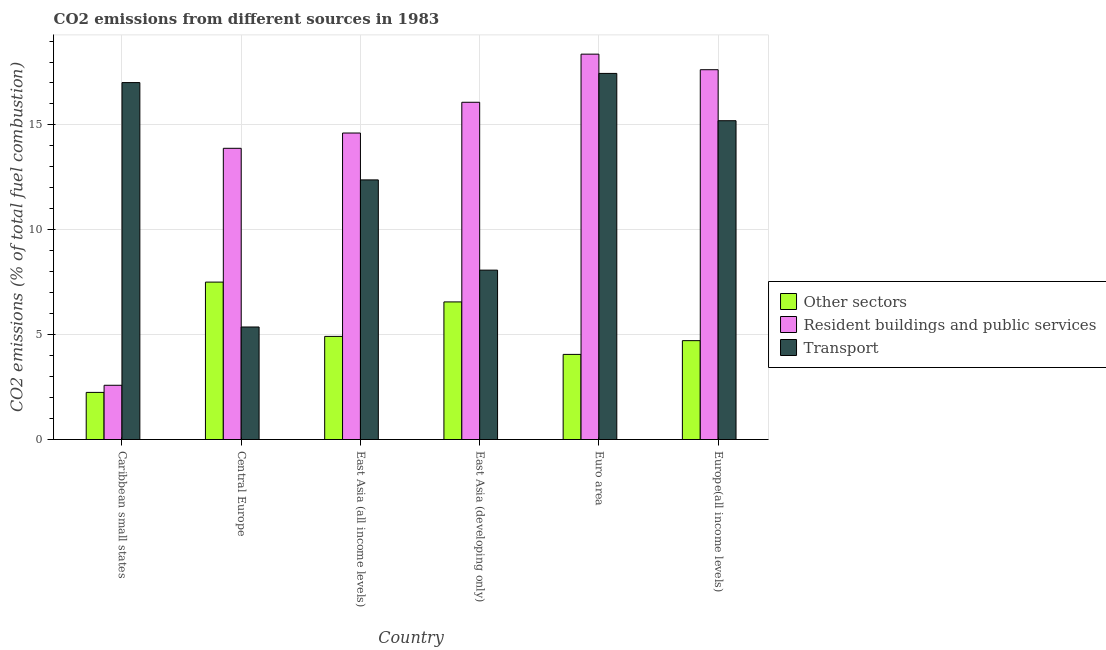Are the number of bars per tick equal to the number of legend labels?
Offer a terse response. Yes. How many bars are there on the 2nd tick from the right?
Offer a very short reply. 3. In how many cases, is the number of bars for a given country not equal to the number of legend labels?
Make the answer very short. 0. What is the percentage of co2 emissions from transport in Europe(all income levels)?
Provide a short and direct response. 15.2. Across all countries, what is the maximum percentage of co2 emissions from other sectors?
Give a very brief answer. 7.51. Across all countries, what is the minimum percentage of co2 emissions from other sectors?
Your answer should be very brief. 2.25. In which country was the percentage of co2 emissions from other sectors maximum?
Your answer should be compact. Central Europe. In which country was the percentage of co2 emissions from transport minimum?
Your answer should be very brief. Central Europe. What is the total percentage of co2 emissions from transport in the graph?
Keep it short and to the point. 75.5. What is the difference between the percentage of co2 emissions from other sectors in Euro area and that in Europe(all income levels)?
Make the answer very short. -0.66. What is the difference between the percentage of co2 emissions from transport in Euro area and the percentage of co2 emissions from resident buildings and public services in Europe(all income levels)?
Your answer should be very brief. -0.18. What is the average percentage of co2 emissions from other sectors per country?
Ensure brevity in your answer.  5. What is the difference between the percentage of co2 emissions from other sectors and percentage of co2 emissions from resident buildings and public services in Europe(all income levels)?
Keep it short and to the point. -12.92. In how many countries, is the percentage of co2 emissions from other sectors greater than 4 %?
Your answer should be very brief. 5. What is the ratio of the percentage of co2 emissions from other sectors in Central Europe to that in East Asia (developing only)?
Your response must be concise. 1.14. Is the percentage of co2 emissions from resident buildings and public services in Central Europe less than that in East Asia (all income levels)?
Your answer should be compact. Yes. Is the difference between the percentage of co2 emissions from other sectors in Central Europe and Euro area greater than the difference between the percentage of co2 emissions from transport in Central Europe and Euro area?
Your answer should be very brief. Yes. What is the difference between the highest and the second highest percentage of co2 emissions from transport?
Offer a very short reply. 0.44. What is the difference between the highest and the lowest percentage of co2 emissions from other sectors?
Your answer should be compact. 5.26. In how many countries, is the percentage of co2 emissions from resident buildings and public services greater than the average percentage of co2 emissions from resident buildings and public services taken over all countries?
Provide a short and direct response. 5. What does the 3rd bar from the left in Caribbean small states represents?
Give a very brief answer. Transport. What does the 3rd bar from the right in East Asia (all income levels) represents?
Offer a very short reply. Other sectors. Are all the bars in the graph horizontal?
Provide a succinct answer. No. How many countries are there in the graph?
Keep it short and to the point. 6. How are the legend labels stacked?
Offer a very short reply. Vertical. What is the title of the graph?
Give a very brief answer. CO2 emissions from different sources in 1983. What is the label or title of the Y-axis?
Give a very brief answer. CO2 emissions (% of total fuel combustion). What is the CO2 emissions (% of total fuel combustion) of Other sectors in Caribbean small states?
Ensure brevity in your answer.  2.25. What is the CO2 emissions (% of total fuel combustion) of Resident buildings and public services in Caribbean small states?
Your answer should be very brief. 2.59. What is the CO2 emissions (% of total fuel combustion) of Transport in Caribbean small states?
Provide a succinct answer. 17.02. What is the CO2 emissions (% of total fuel combustion) in Other sectors in Central Europe?
Offer a very short reply. 7.51. What is the CO2 emissions (% of total fuel combustion) of Resident buildings and public services in Central Europe?
Give a very brief answer. 13.88. What is the CO2 emissions (% of total fuel combustion) of Transport in Central Europe?
Offer a terse response. 5.37. What is the CO2 emissions (% of total fuel combustion) of Other sectors in East Asia (all income levels)?
Your response must be concise. 4.92. What is the CO2 emissions (% of total fuel combustion) in Resident buildings and public services in East Asia (all income levels)?
Your answer should be very brief. 14.61. What is the CO2 emissions (% of total fuel combustion) of Transport in East Asia (all income levels)?
Give a very brief answer. 12.38. What is the CO2 emissions (% of total fuel combustion) of Other sectors in East Asia (developing only)?
Offer a terse response. 6.56. What is the CO2 emissions (% of total fuel combustion) in Resident buildings and public services in East Asia (developing only)?
Your answer should be compact. 16.08. What is the CO2 emissions (% of total fuel combustion) in Transport in East Asia (developing only)?
Offer a terse response. 8.08. What is the CO2 emissions (% of total fuel combustion) of Other sectors in Euro area?
Ensure brevity in your answer.  4.06. What is the CO2 emissions (% of total fuel combustion) in Resident buildings and public services in Euro area?
Give a very brief answer. 18.37. What is the CO2 emissions (% of total fuel combustion) of Transport in Euro area?
Offer a terse response. 17.46. What is the CO2 emissions (% of total fuel combustion) of Other sectors in Europe(all income levels)?
Give a very brief answer. 4.71. What is the CO2 emissions (% of total fuel combustion) of Resident buildings and public services in Europe(all income levels)?
Your response must be concise. 17.63. What is the CO2 emissions (% of total fuel combustion) in Transport in Europe(all income levels)?
Make the answer very short. 15.2. Across all countries, what is the maximum CO2 emissions (% of total fuel combustion) of Other sectors?
Offer a very short reply. 7.51. Across all countries, what is the maximum CO2 emissions (% of total fuel combustion) of Resident buildings and public services?
Your answer should be compact. 18.37. Across all countries, what is the maximum CO2 emissions (% of total fuel combustion) of Transport?
Make the answer very short. 17.46. Across all countries, what is the minimum CO2 emissions (% of total fuel combustion) of Other sectors?
Offer a very short reply. 2.25. Across all countries, what is the minimum CO2 emissions (% of total fuel combustion) in Resident buildings and public services?
Keep it short and to the point. 2.59. Across all countries, what is the minimum CO2 emissions (% of total fuel combustion) in Transport?
Provide a short and direct response. 5.37. What is the total CO2 emissions (% of total fuel combustion) in Other sectors in the graph?
Ensure brevity in your answer.  30. What is the total CO2 emissions (% of total fuel combustion) in Resident buildings and public services in the graph?
Give a very brief answer. 83.17. What is the total CO2 emissions (% of total fuel combustion) in Transport in the graph?
Ensure brevity in your answer.  75.5. What is the difference between the CO2 emissions (% of total fuel combustion) of Other sectors in Caribbean small states and that in Central Europe?
Keep it short and to the point. -5.26. What is the difference between the CO2 emissions (% of total fuel combustion) of Resident buildings and public services in Caribbean small states and that in Central Europe?
Offer a terse response. -11.3. What is the difference between the CO2 emissions (% of total fuel combustion) of Transport in Caribbean small states and that in Central Europe?
Make the answer very short. 11.65. What is the difference between the CO2 emissions (% of total fuel combustion) of Other sectors in Caribbean small states and that in East Asia (all income levels)?
Provide a succinct answer. -2.67. What is the difference between the CO2 emissions (% of total fuel combustion) of Resident buildings and public services in Caribbean small states and that in East Asia (all income levels)?
Make the answer very short. -12.03. What is the difference between the CO2 emissions (% of total fuel combustion) of Transport in Caribbean small states and that in East Asia (all income levels)?
Your response must be concise. 4.64. What is the difference between the CO2 emissions (% of total fuel combustion) in Other sectors in Caribbean small states and that in East Asia (developing only)?
Your response must be concise. -4.31. What is the difference between the CO2 emissions (% of total fuel combustion) in Resident buildings and public services in Caribbean small states and that in East Asia (developing only)?
Your response must be concise. -13.49. What is the difference between the CO2 emissions (% of total fuel combustion) in Transport in Caribbean small states and that in East Asia (developing only)?
Give a very brief answer. 8.94. What is the difference between the CO2 emissions (% of total fuel combustion) of Other sectors in Caribbean small states and that in Euro area?
Your answer should be compact. -1.81. What is the difference between the CO2 emissions (% of total fuel combustion) of Resident buildings and public services in Caribbean small states and that in Euro area?
Make the answer very short. -15.79. What is the difference between the CO2 emissions (% of total fuel combustion) of Transport in Caribbean small states and that in Euro area?
Your answer should be very brief. -0.44. What is the difference between the CO2 emissions (% of total fuel combustion) of Other sectors in Caribbean small states and that in Europe(all income levels)?
Offer a very short reply. -2.47. What is the difference between the CO2 emissions (% of total fuel combustion) of Resident buildings and public services in Caribbean small states and that in Europe(all income levels)?
Your response must be concise. -15.05. What is the difference between the CO2 emissions (% of total fuel combustion) in Transport in Caribbean small states and that in Europe(all income levels)?
Your answer should be compact. 1.82. What is the difference between the CO2 emissions (% of total fuel combustion) of Other sectors in Central Europe and that in East Asia (all income levels)?
Provide a succinct answer. 2.59. What is the difference between the CO2 emissions (% of total fuel combustion) of Resident buildings and public services in Central Europe and that in East Asia (all income levels)?
Ensure brevity in your answer.  -0.73. What is the difference between the CO2 emissions (% of total fuel combustion) in Transport in Central Europe and that in East Asia (all income levels)?
Make the answer very short. -7.01. What is the difference between the CO2 emissions (% of total fuel combustion) in Other sectors in Central Europe and that in East Asia (developing only)?
Offer a very short reply. 0.94. What is the difference between the CO2 emissions (% of total fuel combustion) of Resident buildings and public services in Central Europe and that in East Asia (developing only)?
Ensure brevity in your answer.  -2.2. What is the difference between the CO2 emissions (% of total fuel combustion) in Transport in Central Europe and that in East Asia (developing only)?
Offer a terse response. -2.71. What is the difference between the CO2 emissions (% of total fuel combustion) of Other sectors in Central Europe and that in Euro area?
Provide a succinct answer. 3.45. What is the difference between the CO2 emissions (% of total fuel combustion) of Resident buildings and public services in Central Europe and that in Euro area?
Provide a short and direct response. -4.49. What is the difference between the CO2 emissions (% of total fuel combustion) of Transport in Central Europe and that in Euro area?
Offer a very short reply. -12.09. What is the difference between the CO2 emissions (% of total fuel combustion) in Other sectors in Central Europe and that in Europe(all income levels)?
Provide a succinct answer. 2.79. What is the difference between the CO2 emissions (% of total fuel combustion) in Resident buildings and public services in Central Europe and that in Europe(all income levels)?
Provide a short and direct response. -3.75. What is the difference between the CO2 emissions (% of total fuel combustion) of Transport in Central Europe and that in Europe(all income levels)?
Keep it short and to the point. -9.84. What is the difference between the CO2 emissions (% of total fuel combustion) of Other sectors in East Asia (all income levels) and that in East Asia (developing only)?
Ensure brevity in your answer.  -1.64. What is the difference between the CO2 emissions (% of total fuel combustion) in Resident buildings and public services in East Asia (all income levels) and that in East Asia (developing only)?
Offer a very short reply. -1.47. What is the difference between the CO2 emissions (% of total fuel combustion) of Transport in East Asia (all income levels) and that in East Asia (developing only)?
Offer a very short reply. 4.3. What is the difference between the CO2 emissions (% of total fuel combustion) in Other sectors in East Asia (all income levels) and that in Euro area?
Offer a very short reply. 0.86. What is the difference between the CO2 emissions (% of total fuel combustion) in Resident buildings and public services in East Asia (all income levels) and that in Euro area?
Provide a short and direct response. -3.76. What is the difference between the CO2 emissions (% of total fuel combustion) in Transport in East Asia (all income levels) and that in Euro area?
Ensure brevity in your answer.  -5.08. What is the difference between the CO2 emissions (% of total fuel combustion) of Other sectors in East Asia (all income levels) and that in Europe(all income levels)?
Your answer should be very brief. 0.2. What is the difference between the CO2 emissions (% of total fuel combustion) of Resident buildings and public services in East Asia (all income levels) and that in Europe(all income levels)?
Your answer should be very brief. -3.02. What is the difference between the CO2 emissions (% of total fuel combustion) of Transport in East Asia (all income levels) and that in Europe(all income levels)?
Your answer should be compact. -2.82. What is the difference between the CO2 emissions (% of total fuel combustion) of Other sectors in East Asia (developing only) and that in Euro area?
Provide a short and direct response. 2.5. What is the difference between the CO2 emissions (% of total fuel combustion) of Resident buildings and public services in East Asia (developing only) and that in Euro area?
Offer a very short reply. -2.29. What is the difference between the CO2 emissions (% of total fuel combustion) of Transport in East Asia (developing only) and that in Euro area?
Your answer should be very brief. -9.38. What is the difference between the CO2 emissions (% of total fuel combustion) in Other sectors in East Asia (developing only) and that in Europe(all income levels)?
Provide a short and direct response. 1.85. What is the difference between the CO2 emissions (% of total fuel combustion) in Resident buildings and public services in East Asia (developing only) and that in Europe(all income levels)?
Your answer should be very brief. -1.55. What is the difference between the CO2 emissions (% of total fuel combustion) of Transport in East Asia (developing only) and that in Europe(all income levels)?
Provide a short and direct response. -7.12. What is the difference between the CO2 emissions (% of total fuel combustion) in Other sectors in Euro area and that in Europe(all income levels)?
Make the answer very short. -0.66. What is the difference between the CO2 emissions (% of total fuel combustion) in Resident buildings and public services in Euro area and that in Europe(all income levels)?
Provide a short and direct response. 0.74. What is the difference between the CO2 emissions (% of total fuel combustion) of Transport in Euro area and that in Europe(all income levels)?
Provide a short and direct response. 2.26. What is the difference between the CO2 emissions (% of total fuel combustion) in Other sectors in Caribbean small states and the CO2 emissions (% of total fuel combustion) in Resident buildings and public services in Central Europe?
Your answer should be very brief. -11.64. What is the difference between the CO2 emissions (% of total fuel combustion) of Other sectors in Caribbean small states and the CO2 emissions (% of total fuel combustion) of Transport in Central Europe?
Provide a succinct answer. -3.12. What is the difference between the CO2 emissions (% of total fuel combustion) in Resident buildings and public services in Caribbean small states and the CO2 emissions (% of total fuel combustion) in Transport in Central Europe?
Offer a terse response. -2.78. What is the difference between the CO2 emissions (% of total fuel combustion) of Other sectors in Caribbean small states and the CO2 emissions (% of total fuel combustion) of Resident buildings and public services in East Asia (all income levels)?
Provide a succinct answer. -12.37. What is the difference between the CO2 emissions (% of total fuel combustion) of Other sectors in Caribbean small states and the CO2 emissions (% of total fuel combustion) of Transport in East Asia (all income levels)?
Your response must be concise. -10.13. What is the difference between the CO2 emissions (% of total fuel combustion) in Resident buildings and public services in Caribbean small states and the CO2 emissions (% of total fuel combustion) in Transport in East Asia (all income levels)?
Your response must be concise. -9.79. What is the difference between the CO2 emissions (% of total fuel combustion) in Other sectors in Caribbean small states and the CO2 emissions (% of total fuel combustion) in Resident buildings and public services in East Asia (developing only)?
Provide a succinct answer. -13.83. What is the difference between the CO2 emissions (% of total fuel combustion) of Other sectors in Caribbean small states and the CO2 emissions (% of total fuel combustion) of Transport in East Asia (developing only)?
Make the answer very short. -5.83. What is the difference between the CO2 emissions (% of total fuel combustion) in Resident buildings and public services in Caribbean small states and the CO2 emissions (% of total fuel combustion) in Transport in East Asia (developing only)?
Your answer should be very brief. -5.49. What is the difference between the CO2 emissions (% of total fuel combustion) of Other sectors in Caribbean small states and the CO2 emissions (% of total fuel combustion) of Resident buildings and public services in Euro area?
Your answer should be compact. -16.13. What is the difference between the CO2 emissions (% of total fuel combustion) of Other sectors in Caribbean small states and the CO2 emissions (% of total fuel combustion) of Transport in Euro area?
Your answer should be very brief. -15.21. What is the difference between the CO2 emissions (% of total fuel combustion) in Resident buildings and public services in Caribbean small states and the CO2 emissions (% of total fuel combustion) in Transport in Euro area?
Keep it short and to the point. -14.87. What is the difference between the CO2 emissions (% of total fuel combustion) in Other sectors in Caribbean small states and the CO2 emissions (% of total fuel combustion) in Resident buildings and public services in Europe(all income levels)?
Provide a succinct answer. -15.39. What is the difference between the CO2 emissions (% of total fuel combustion) in Other sectors in Caribbean small states and the CO2 emissions (% of total fuel combustion) in Transport in Europe(all income levels)?
Ensure brevity in your answer.  -12.95. What is the difference between the CO2 emissions (% of total fuel combustion) in Resident buildings and public services in Caribbean small states and the CO2 emissions (% of total fuel combustion) in Transport in Europe(all income levels)?
Provide a short and direct response. -12.61. What is the difference between the CO2 emissions (% of total fuel combustion) of Other sectors in Central Europe and the CO2 emissions (% of total fuel combustion) of Resident buildings and public services in East Asia (all income levels)?
Offer a terse response. -7.11. What is the difference between the CO2 emissions (% of total fuel combustion) in Other sectors in Central Europe and the CO2 emissions (% of total fuel combustion) in Transport in East Asia (all income levels)?
Your response must be concise. -4.87. What is the difference between the CO2 emissions (% of total fuel combustion) in Resident buildings and public services in Central Europe and the CO2 emissions (% of total fuel combustion) in Transport in East Asia (all income levels)?
Offer a terse response. 1.51. What is the difference between the CO2 emissions (% of total fuel combustion) of Other sectors in Central Europe and the CO2 emissions (% of total fuel combustion) of Resident buildings and public services in East Asia (developing only)?
Make the answer very short. -8.57. What is the difference between the CO2 emissions (% of total fuel combustion) of Other sectors in Central Europe and the CO2 emissions (% of total fuel combustion) of Transport in East Asia (developing only)?
Provide a succinct answer. -0.57. What is the difference between the CO2 emissions (% of total fuel combustion) of Resident buildings and public services in Central Europe and the CO2 emissions (% of total fuel combustion) of Transport in East Asia (developing only)?
Keep it short and to the point. 5.81. What is the difference between the CO2 emissions (% of total fuel combustion) in Other sectors in Central Europe and the CO2 emissions (% of total fuel combustion) in Resident buildings and public services in Euro area?
Offer a terse response. -10.87. What is the difference between the CO2 emissions (% of total fuel combustion) of Other sectors in Central Europe and the CO2 emissions (% of total fuel combustion) of Transport in Euro area?
Keep it short and to the point. -9.95. What is the difference between the CO2 emissions (% of total fuel combustion) of Resident buildings and public services in Central Europe and the CO2 emissions (% of total fuel combustion) of Transport in Euro area?
Offer a terse response. -3.57. What is the difference between the CO2 emissions (% of total fuel combustion) of Other sectors in Central Europe and the CO2 emissions (% of total fuel combustion) of Resident buildings and public services in Europe(all income levels)?
Keep it short and to the point. -10.13. What is the difference between the CO2 emissions (% of total fuel combustion) of Other sectors in Central Europe and the CO2 emissions (% of total fuel combustion) of Transport in Europe(all income levels)?
Give a very brief answer. -7.7. What is the difference between the CO2 emissions (% of total fuel combustion) of Resident buildings and public services in Central Europe and the CO2 emissions (% of total fuel combustion) of Transport in Europe(all income levels)?
Offer a terse response. -1.32. What is the difference between the CO2 emissions (% of total fuel combustion) in Other sectors in East Asia (all income levels) and the CO2 emissions (% of total fuel combustion) in Resident buildings and public services in East Asia (developing only)?
Your answer should be compact. -11.16. What is the difference between the CO2 emissions (% of total fuel combustion) of Other sectors in East Asia (all income levels) and the CO2 emissions (% of total fuel combustion) of Transport in East Asia (developing only)?
Keep it short and to the point. -3.16. What is the difference between the CO2 emissions (% of total fuel combustion) of Resident buildings and public services in East Asia (all income levels) and the CO2 emissions (% of total fuel combustion) of Transport in East Asia (developing only)?
Your answer should be very brief. 6.54. What is the difference between the CO2 emissions (% of total fuel combustion) of Other sectors in East Asia (all income levels) and the CO2 emissions (% of total fuel combustion) of Resident buildings and public services in Euro area?
Offer a very short reply. -13.46. What is the difference between the CO2 emissions (% of total fuel combustion) in Other sectors in East Asia (all income levels) and the CO2 emissions (% of total fuel combustion) in Transport in Euro area?
Your answer should be very brief. -12.54. What is the difference between the CO2 emissions (% of total fuel combustion) of Resident buildings and public services in East Asia (all income levels) and the CO2 emissions (% of total fuel combustion) of Transport in Euro area?
Provide a short and direct response. -2.84. What is the difference between the CO2 emissions (% of total fuel combustion) of Other sectors in East Asia (all income levels) and the CO2 emissions (% of total fuel combustion) of Resident buildings and public services in Europe(all income levels)?
Offer a terse response. -12.72. What is the difference between the CO2 emissions (% of total fuel combustion) in Other sectors in East Asia (all income levels) and the CO2 emissions (% of total fuel combustion) in Transport in Europe(all income levels)?
Keep it short and to the point. -10.28. What is the difference between the CO2 emissions (% of total fuel combustion) in Resident buildings and public services in East Asia (all income levels) and the CO2 emissions (% of total fuel combustion) in Transport in Europe(all income levels)?
Your response must be concise. -0.59. What is the difference between the CO2 emissions (% of total fuel combustion) of Other sectors in East Asia (developing only) and the CO2 emissions (% of total fuel combustion) of Resident buildings and public services in Euro area?
Offer a terse response. -11.81. What is the difference between the CO2 emissions (% of total fuel combustion) of Other sectors in East Asia (developing only) and the CO2 emissions (% of total fuel combustion) of Transport in Euro area?
Offer a very short reply. -10.89. What is the difference between the CO2 emissions (% of total fuel combustion) in Resident buildings and public services in East Asia (developing only) and the CO2 emissions (% of total fuel combustion) in Transport in Euro area?
Ensure brevity in your answer.  -1.38. What is the difference between the CO2 emissions (% of total fuel combustion) in Other sectors in East Asia (developing only) and the CO2 emissions (% of total fuel combustion) in Resident buildings and public services in Europe(all income levels)?
Your answer should be very brief. -11.07. What is the difference between the CO2 emissions (% of total fuel combustion) in Other sectors in East Asia (developing only) and the CO2 emissions (% of total fuel combustion) in Transport in Europe(all income levels)?
Offer a very short reply. -8.64. What is the difference between the CO2 emissions (% of total fuel combustion) of Resident buildings and public services in East Asia (developing only) and the CO2 emissions (% of total fuel combustion) of Transport in Europe(all income levels)?
Keep it short and to the point. 0.88. What is the difference between the CO2 emissions (% of total fuel combustion) in Other sectors in Euro area and the CO2 emissions (% of total fuel combustion) in Resident buildings and public services in Europe(all income levels)?
Your response must be concise. -13.57. What is the difference between the CO2 emissions (% of total fuel combustion) in Other sectors in Euro area and the CO2 emissions (% of total fuel combustion) in Transport in Europe(all income levels)?
Make the answer very short. -11.14. What is the difference between the CO2 emissions (% of total fuel combustion) of Resident buildings and public services in Euro area and the CO2 emissions (% of total fuel combustion) of Transport in Europe(all income levels)?
Keep it short and to the point. 3.17. What is the average CO2 emissions (% of total fuel combustion) in Other sectors per country?
Make the answer very short. 5. What is the average CO2 emissions (% of total fuel combustion) in Resident buildings and public services per country?
Offer a terse response. 13.86. What is the average CO2 emissions (% of total fuel combustion) in Transport per country?
Provide a short and direct response. 12.58. What is the difference between the CO2 emissions (% of total fuel combustion) of Other sectors and CO2 emissions (% of total fuel combustion) of Resident buildings and public services in Caribbean small states?
Your response must be concise. -0.34. What is the difference between the CO2 emissions (% of total fuel combustion) in Other sectors and CO2 emissions (% of total fuel combustion) in Transport in Caribbean small states?
Your answer should be compact. -14.77. What is the difference between the CO2 emissions (% of total fuel combustion) of Resident buildings and public services and CO2 emissions (% of total fuel combustion) of Transport in Caribbean small states?
Your answer should be compact. -14.43. What is the difference between the CO2 emissions (% of total fuel combustion) in Other sectors and CO2 emissions (% of total fuel combustion) in Resident buildings and public services in Central Europe?
Ensure brevity in your answer.  -6.38. What is the difference between the CO2 emissions (% of total fuel combustion) of Other sectors and CO2 emissions (% of total fuel combustion) of Transport in Central Europe?
Your answer should be very brief. 2.14. What is the difference between the CO2 emissions (% of total fuel combustion) in Resident buildings and public services and CO2 emissions (% of total fuel combustion) in Transport in Central Europe?
Provide a short and direct response. 8.52. What is the difference between the CO2 emissions (% of total fuel combustion) in Other sectors and CO2 emissions (% of total fuel combustion) in Resident buildings and public services in East Asia (all income levels)?
Ensure brevity in your answer.  -9.7. What is the difference between the CO2 emissions (% of total fuel combustion) in Other sectors and CO2 emissions (% of total fuel combustion) in Transport in East Asia (all income levels)?
Keep it short and to the point. -7.46. What is the difference between the CO2 emissions (% of total fuel combustion) of Resident buildings and public services and CO2 emissions (% of total fuel combustion) of Transport in East Asia (all income levels)?
Offer a very short reply. 2.24. What is the difference between the CO2 emissions (% of total fuel combustion) of Other sectors and CO2 emissions (% of total fuel combustion) of Resident buildings and public services in East Asia (developing only)?
Your answer should be very brief. -9.52. What is the difference between the CO2 emissions (% of total fuel combustion) in Other sectors and CO2 emissions (% of total fuel combustion) in Transport in East Asia (developing only)?
Provide a succinct answer. -1.52. What is the difference between the CO2 emissions (% of total fuel combustion) of Resident buildings and public services and CO2 emissions (% of total fuel combustion) of Transport in East Asia (developing only)?
Provide a succinct answer. 8. What is the difference between the CO2 emissions (% of total fuel combustion) in Other sectors and CO2 emissions (% of total fuel combustion) in Resident buildings and public services in Euro area?
Your answer should be very brief. -14.32. What is the difference between the CO2 emissions (% of total fuel combustion) in Other sectors and CO2 emissions (% of total fuel combustion) in Transport in Euro area?
Your response must be concise. -13.4. What is the difference between the CO2 emissions (% of total fuel combustion) in Resident buildings and public services and CO2 emissions (% of total fuel combustion) in Transport in Euro area?
Your answer should be compact. 0.92. What is the difference between the CO2 emissions (% of total fuel combustion) in Other sectors and CO2 emissions (% of total fuel combustion) in Resident buildings and public services in Europe(all income levels)?
Keep it short and to the point. -12.92. What is the difference between the CO2 emissions (% of total fuel combustion) of Other sectors and CO2 emissions (% of total fuel combustion) of Transport in Europe(all income levels)?
Ensure brevity in your answer.  -10.49. What is the difference between the CO2 emissions (% of total fuel combustion) of Resident buildings and public services and CO2 emissions (% of total fuel combustion) of Transport in Europe(all income levels)?
Your response must be concise. 2.43. What is the ratio of the CO2 emissions (% of total fuel combustion) in Other sectors in Caribbean small states to that in Central Europe?
Ensure brevity in your answer.  0.3. What is the ratio of the CO2 emissions (% of total fuel combustion) of Resident buildings and public services in Caribbean small states to that in Central Europe?
Offer a very short reply. 0.19. What is the ratio of the CO2 emissions (% of total fuel combustion) of Transport in Caribbean small states to that in Central Europe?
Ensure brevity in your answer.  3.17. What is the ratio of the CO2 emissions (% of total fuel combustion) in Other sectors in Caribbean small states to that in East Asia (all income levels)?
Offer a very short reply. 0.46. What is the ratio of the CO2 emissions (% of total fuel combustion) in Resident buildings and public services in Caribbean small states to that in East Asia (all income levels)?
Your answer should be very brief. 0.18. What is the ratio of the CO2 emissions (% of total fuel combustion) in Transport in Caribbean small states to that in East Asia (all income levels)?
Ensure brevity in your answer.  1.37. What is the ratio of the CO2 emissions (% of total fuel combustion) in Other sectors in Caribbean small states to that in East Asia (developing only)?
Provide a succinct answer. 0.34. What is the ratio of the CO2 emissions (% of total fuel combustion) of Resident buildings and public services in Caribbean small states to that in East Asia (developing only)?
Make the answer very short. 0.16. What is the ratio of the CO2 emissions (% of total fuel combustion) in Transport in Caribbean small states to that in East Asia (developing only)?
Provide a succinct answer. 2.11. What is the ratio of the CO2 emissions (% of total fuel combustion) of Other sectors in Caribbean small states to that in Euro area?
Provide a short and direct response. 0.55. What is the ratio of the CO2 emissions (% of total fuel combustion) of Resident buildings and public services in Caribbean small states to that in Euro area?
Your answer should be very brief. 0.14. What is the ratio of the CO2 emissions (% of total fuel combustion) of Transport in Caribbean small states to that in Euro area?
Your answer should be compact. 0.97. What is the ratio of the CO2 emissions (% of total fuel combustion) of Other sectors in Caribbean small states to that in Europe(all income levels)?
Your response must be concise. 0.48. What is the ratio of the CO2 emissions (% of total fuel combustion) in Resident buildings and public services in Caribbean small states to that in Europe(all income levels)?
Your answer should be compact. 0.15. What is the ratio of the CO2 emissions (% of total fuel combustion) in Transport in Caribbean small states to that in Europe(all income levels)?
Offer a very short reply. 1.12. What is the ratio of the CO2 emissions (% of total fuel combustion) of Other sectors in Central Europe to that in East Asia (all income levels)?
Offer a very short reply. 1.53. What is the ratio of the CO2 emissions (% of total fuel combustion) of Resident buildings and public services in Central Europe to that in East Asia (all income levels)?
Offer a terse response. 0.95. What is the ratio of the CO2 emissions (% of total fuel combustion) of Transport in Central Europe to that in East Asia (all income levels)?
Make the answer very short. 0.43. What is the ratio of the CO2 emissions (% of total fuel combustion) in Other sectors in Central Europe to that in East Asia (developing only)?
Provide a succinct answer. 1.14. What is the ratio of the CO2 emissions (% of total fuel combustion) of Resident buildings and public services in Central Europe to that in East Asia (developing only)?
Offer a very short reply. 0.86. What is the ratio of the CO2 emissions (% of total fuel combustion) in Transport in Central Europe to that in East Asia (developing only)?
Give a very brief answer. 0.66. What is the ratio of the CO2 emissions (% of total fuel combustion) in Other sectors in Central Europe to that in Euro area?
Keep it short and to the point. 1.85. What is the ratio of the CO2 emissions (% of total fuel combustion) of Resident buildings and public services in Central Europe to that in Euro area?
Offer a very short reply. 0.76. What is the ratio of the CO2 emissions (% of total fuel combustion) in Transport in Central Europe to that in Euro area?
Your answer should be very brief. 0.31. What is the ratio of the CO2 emissions (% of total fuel combustion) in Other sectors in Central Europe to that in Europe(all income levels)?
Your response must be concise. 1.59. What is the ratio of the CO2 emissions (% of total fuel combustion) of Resident buildings and public services in Central Europe to that in Europe(all income levels)?
Offer a very short reply. 0.79. What is the ratio of the CO2 emissions (% of total fuel combustion) in Transport in Central Europe to that in Europe(all income levels)?
Give a very brief answer. 0.35. What is the ratio of the CO2 emissions (% of total fuel combustion) in Other sectors in East Asia (all income levels) to that in East Asia (developing only)?
Provide a short and direct response. 0.75. What is the ratio of the CO2 emissions (% of total fuel combustion) in Resident buildings and public services in East Asia (all income levels) to that in East Asia (developing only)?
Provide a succinct answer. 0.91. What is the ratio of the CO2 emissions (% of total fuel combustion) in Transport in East Asia (all income levels) to that in East Asia (developing only)?
Your response must be concise. 1.53. What is the ratio of the CO2 emissions (% of total fuel combustion) of Other sectors in East Asia (all income levels) to that in Euro area?
Give a very brief answer. 1.21. What is the ratio of the CO2 emissions (% of total fuel combustion) of Resident buildings and public services in East Asia (all income levels) to that in Euro area?
Your response must be concise. 0.8. What is the ratio of the CO2 emissions (% of total fuel combustion) of Transport in East Asia (all income levels) to that in Euro area?
Provide a succinct answer. 0.71. What is the ratio of the CO2 emissions (% of total fuel combustion) in Other sectors in East Asia (all income levels) to that in Europe(all income levels)?
Your answer should be very brief. 1.04. What is the ratio of the CO2 emissions (% of total fuel combustion) in Resident buildings and public services in East Asia (all income levels) to that in Europe(all income levels)?
Offer a terse response. 0.83. What is the ratio of the CO2 emissions (% of total fuel combustion) of Transport in East Asia (all income levels) to that in Europe(all income levels)?
Provide a succinct answer. 0.81. What is the ratio of the CO2 emissions (% of total fuel combustion) of Other sectors in East Asia (developing only) to that in Euro area?
Give a very brief answer. 1.62. What is the ratio of the CO2 emissions (% of total fuel combustion) in Resident buildings and public services in East Asia (developing only) to that in Euro area?
Provide a short and direct response. 0.88. What is the ratio of the CO2 emissions (% of total fuel combustion) of Transport in East Asia (developing only) to that in Euro area?
Provide a short and direct response. 0.46. What is the ratio of the CO2 emissions (% of total fuel combustion) in Other sectors in East Asia (developing only) to that in Europe(all income levels)?
Keep it short and to the point. 1.39. What is the ratio of the CO2 emissions (% of total fuel combustion) in Resident buildings and public services in East Asia (developing only) to that in Europe(all income levels)?
Give a very brief answer. 0.91. What is the ratio of the CO2 emissions (% of total fuel combustion) in Transport in East Asia (developing only) to that in Europe(all income levels)?
Offer a very short reply. 0.53. What is the ratio of the CO2 emissions (% of total fuel combustion) in Other sectors in Euro area to that in Europe(all income levels)?
Make the answer very short. 0.86. What is the ratio of the CO2 emissions (% of total fuel combustion) of Resident buildings and public services in Euro area to that in Europe(all income levels)?
Provide a short and direct response. 1.04. What is the ratio of the CO2 emissions (% of total fuel combustion) of Transport in Euro area to that in Europe(all income levels)?
Make the answer very short. 1.15. What is the difference between the highest and the second highest CO2 emissions (% of total fuel combustion) of Other sectors?
Provide a succinct answer. 0.94. What is the difference between the highest and the second highest CO2 emissions (% of total fuel combustion) in Resident buildings and public services?
Offer a very short reply. 0.74. What is the difference between the highest and the second highest CO2 emissions (% of total fuel combustion) of Transport?
Offer a very short reply. 0.44. What is the difference between the highest and the lowest CO2 emissions (% of total fuel combustion) of Other sectors?
Ensure brevity in your answer.  5.26. What is the difference between the highest and the lowest CO2 emissions (% of total fuel combustion) of Resident buildings and public services?
Give a very brief answer. 15.79. What is the difference between the highest and the lowest CO2 emissions (% of total fuel combustion) in Transport?
Give a very brief answer. 12.09. 